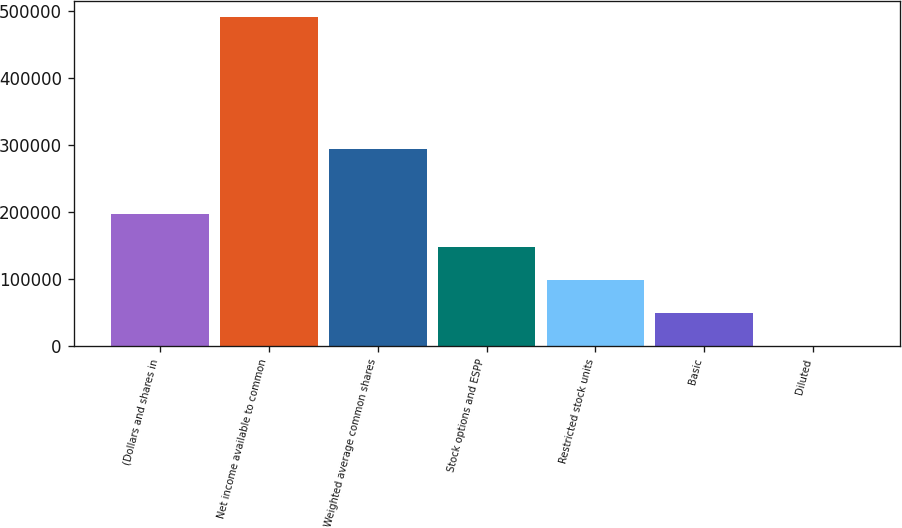Convert chart. <chart><loc_0><loc_0><loc_500><loc_500><bar_chart><fcel>(Dollars and shares in<fcel>Net income available to common<fcel>Weighted average common shares<fcel>Stock options and ESPP<fcel>Restricted stock units<fcel>Basic<fcel>Diluted<nl><fcel>196208<fcel>490506<fcel>294307<fcel>147158<fcel>98108.6<fcel>49058.9<fcel>9.2<nl></chart> 